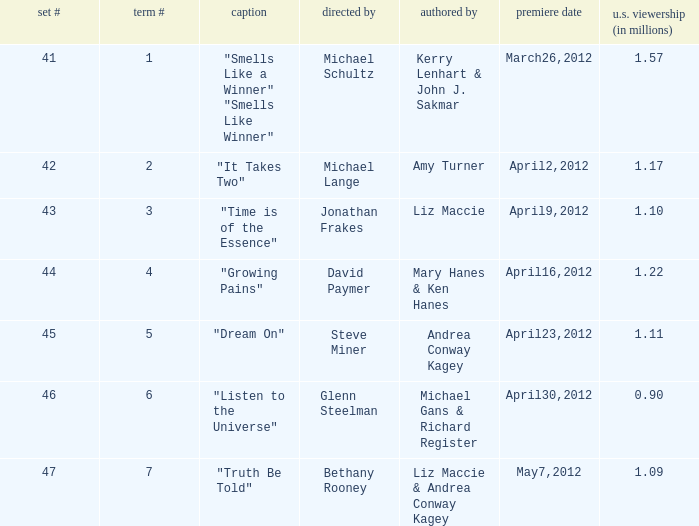What is the name of the episodes which had 1.22 million U.S. viewers? "Growing Pains". 